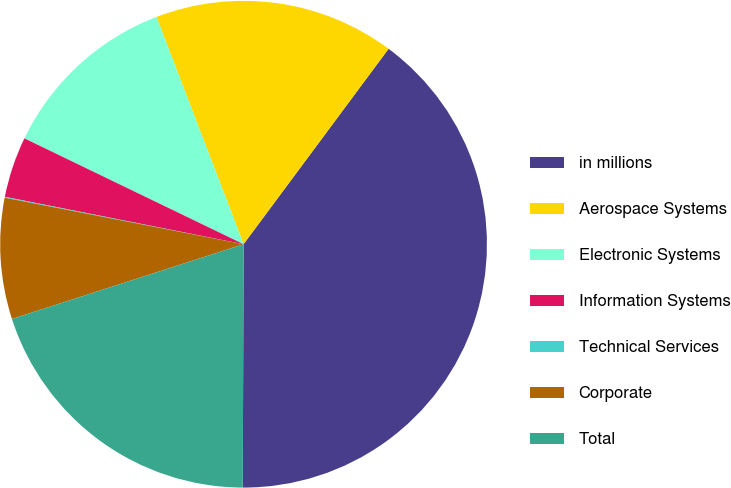Convert chart to OTSL. <chart><loc_0><loc_0><loc_500><loc_500><pie_chart><fcel>in millions<fcel>Aerospace Systems<fcel>Electronic Systems<fcel>Information Systems<fcel>Technical Services<fcel>Corporate<fcel>Total<nl><fcel>39.89%<fcel>15.99%<fcel>12.01%<fcel>4.04%<fcel>0.06%<fcel>8.03%<fcel>19.98%<nl></chart> 